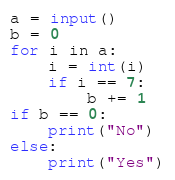Convert code to text. <code><loc_0><loc_0><loc_500><loc_500><_Python_>a = input()
b = 0
for i in a:
    i = int(i)
    if i == 7:
        b += 1
if b == 0:
    print("No")
else:
    print("Yes")</code> 